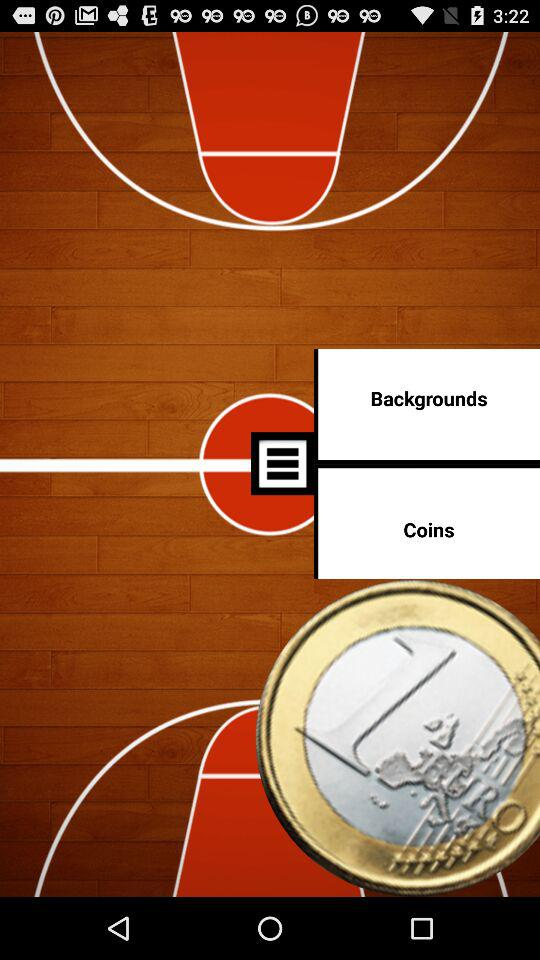How many more coins are there than backgrounds?
Answer the question using a single word or phrase. 1 